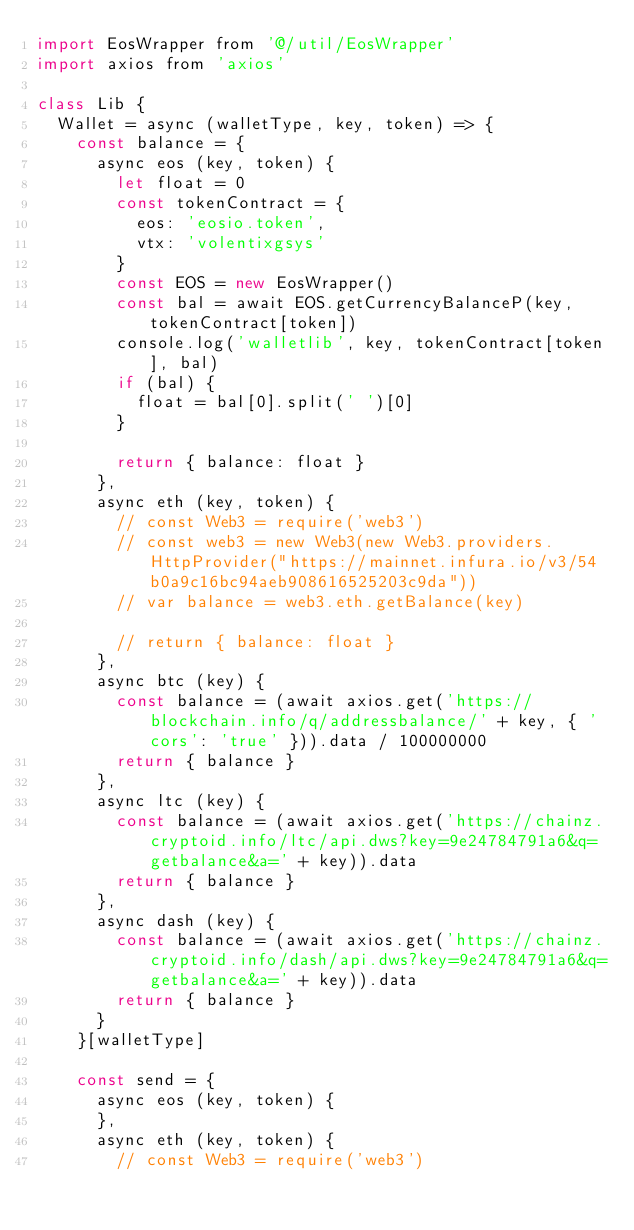Convert code to text. <code><loc_0><loc_0><loc_500><loc_500><_JavaScript_>import EosWrapper from '@/util/EosWrapper'
import axios from 'axios'

class Lib {
  Wallet = async (walletType, key, token) => {
    const balance = {
      async eos (key, token) {
        let float = 0
        const tokenContract = {
          eos: 'eosio.token',
          vtx: 'volentixgsys'
        }
        const EOS = new EosWrapper()
        const bal = await EOS.getCurrencyBalanceP(key, tokenContract[token])
        console.log('walletlib', key, tokenContract[token], bal)
        if (bal) {
          float = bal[0].split(' ')[0]
        }

        return { balance: float }
      },
      async eth (key, token) {
        // const Web3 = require('web3')
        // const web3 = new Web3(new Web3.providers.HttpProvider("https://mainnet.infura.io/v3/54b0a9c16bc94aeb908616525203c9da"))
        // var balance = web3.eth.getBalance(key)

        // return { balance: float }
      },
      async btc (key) {
        const balance = (await axios.get('https://blockchain.info/q/addressbalance/' + key, { 'cors': 'true' })).data / 100000000
        return { balance }
      },
      async ltc (key) {
        const balance = (await axios.get('https://chainz.cryptoid.info/ltc/api.dws?key=9e24784791a6&q=getbalance&a=' + key)).data
        return { balance }
      },
      async dash (key) {
        const balance = (await axios.get('https://chainz.cryptoid.info/dash/api.dws?key=9e24784791a6&q=getbalance&a=' + key)).data
        return { balance }
      }
    }[walletType]

    const send = {
      async eos (key, token) {
      },
      async eth (key, token) {
        // const Web3 = require('web3')</code> 